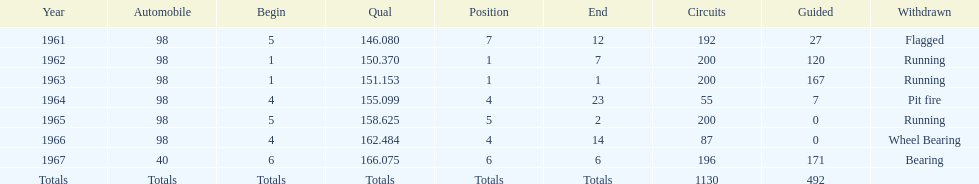Parse the full table. {'header': ['Year', 'Automobile', 'Begin', 'Qual', 'Position', 'End', 'Circuits', 'Guided', 'Withdrawn'], 'rows': [['1961', '98', '5', '146.080', '7', '12', '192', '27', 'Flagged'], ['1962', '98', '1', '150.370', '1', '7', '200', '120', 'Running'], ['1963', '98', '1', '151.153', '1', '1', '200', '167', 'Running'], ['1964', '98', '4', '155.099', '4', '23', '55', '7', 'Pit fire'], ['1965', '98', '5', '158.625', '5', '2', '200', '0', 'Running'], ['1966', '98', '4', '162.484', '4', '14', '87', '0', 'Wheel Bearing'], ['1967', '40', '6', '166.075', '6', '6', '196', '171', 'Bearing'], ['Totals', 'Totals', 'Totals', 'Totals', 'Totals', 'Totals', '1130', '492', '']]} What is the most common cause for a retired car? Running. 